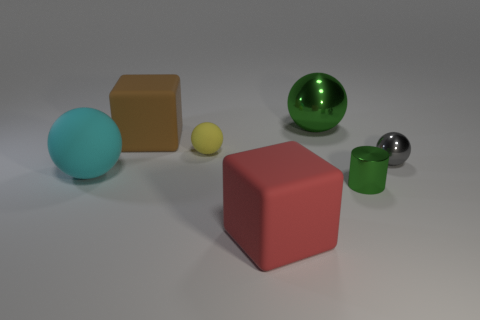There is a metallic sphere left of the metal sphere that is right of the shiny cylinder; is there a metallic object right of it?
Offer a terse response. Yes. What number of shiny things are green objects or large balls?
Provide a short and direct response. 2. Is the small metal cylinder the same color as the tiny metallic sphere?
Your answer should be compact. No. There is a small green metal cylinder; how many shiny balls are behind it?
Provide a short and direct response. 2. What number of large rubber objects are both behind the shiny cylinder and right of the big cyan sphere?
Give a very brief answer. 1. There is a yellow thing that is the same material as the cyan sphere; what is its shape?
Your response must be concise. Sphere. Does the cube in front of the shiny cylinder have the same size as the green metal object that is behind the tiny cylinder?
Provide a succinct answer. Yes. The rubber object in front of the tiny green metal object is what color?
Provide a short and direct response. Red. The big ball that is behind the big sphere that is on the left side of the red matte cube is made of what material?
Offer a terse response. Metal. What is the shape of the small green metallic thing?
Provide a short and direct response. Cylinder. 